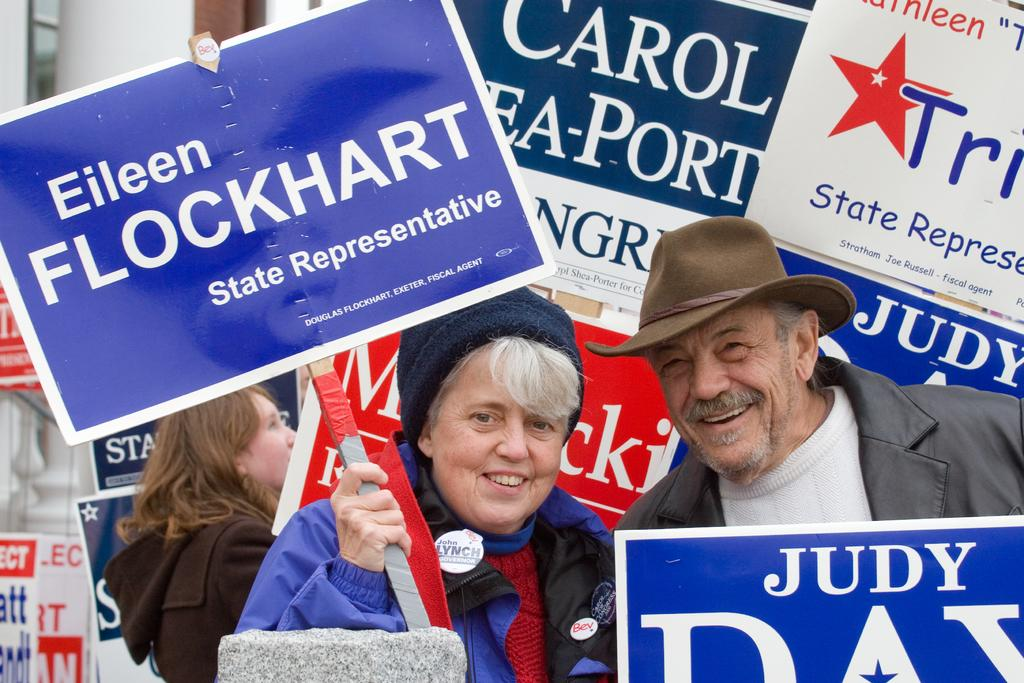Who is present in the image? There are people in the image. What is the woman holding in the image? The woman is holding a board. Can you describe the boards in the image? There are boards with text in the image. What can be seen in the foreground of the image? There is a stone in the foreground of the image. What time is displayed on the clock in the image? There is no clock present in the image. What type of glove is the woman wearing in the image? The woman is not wearing a glove in the image. 